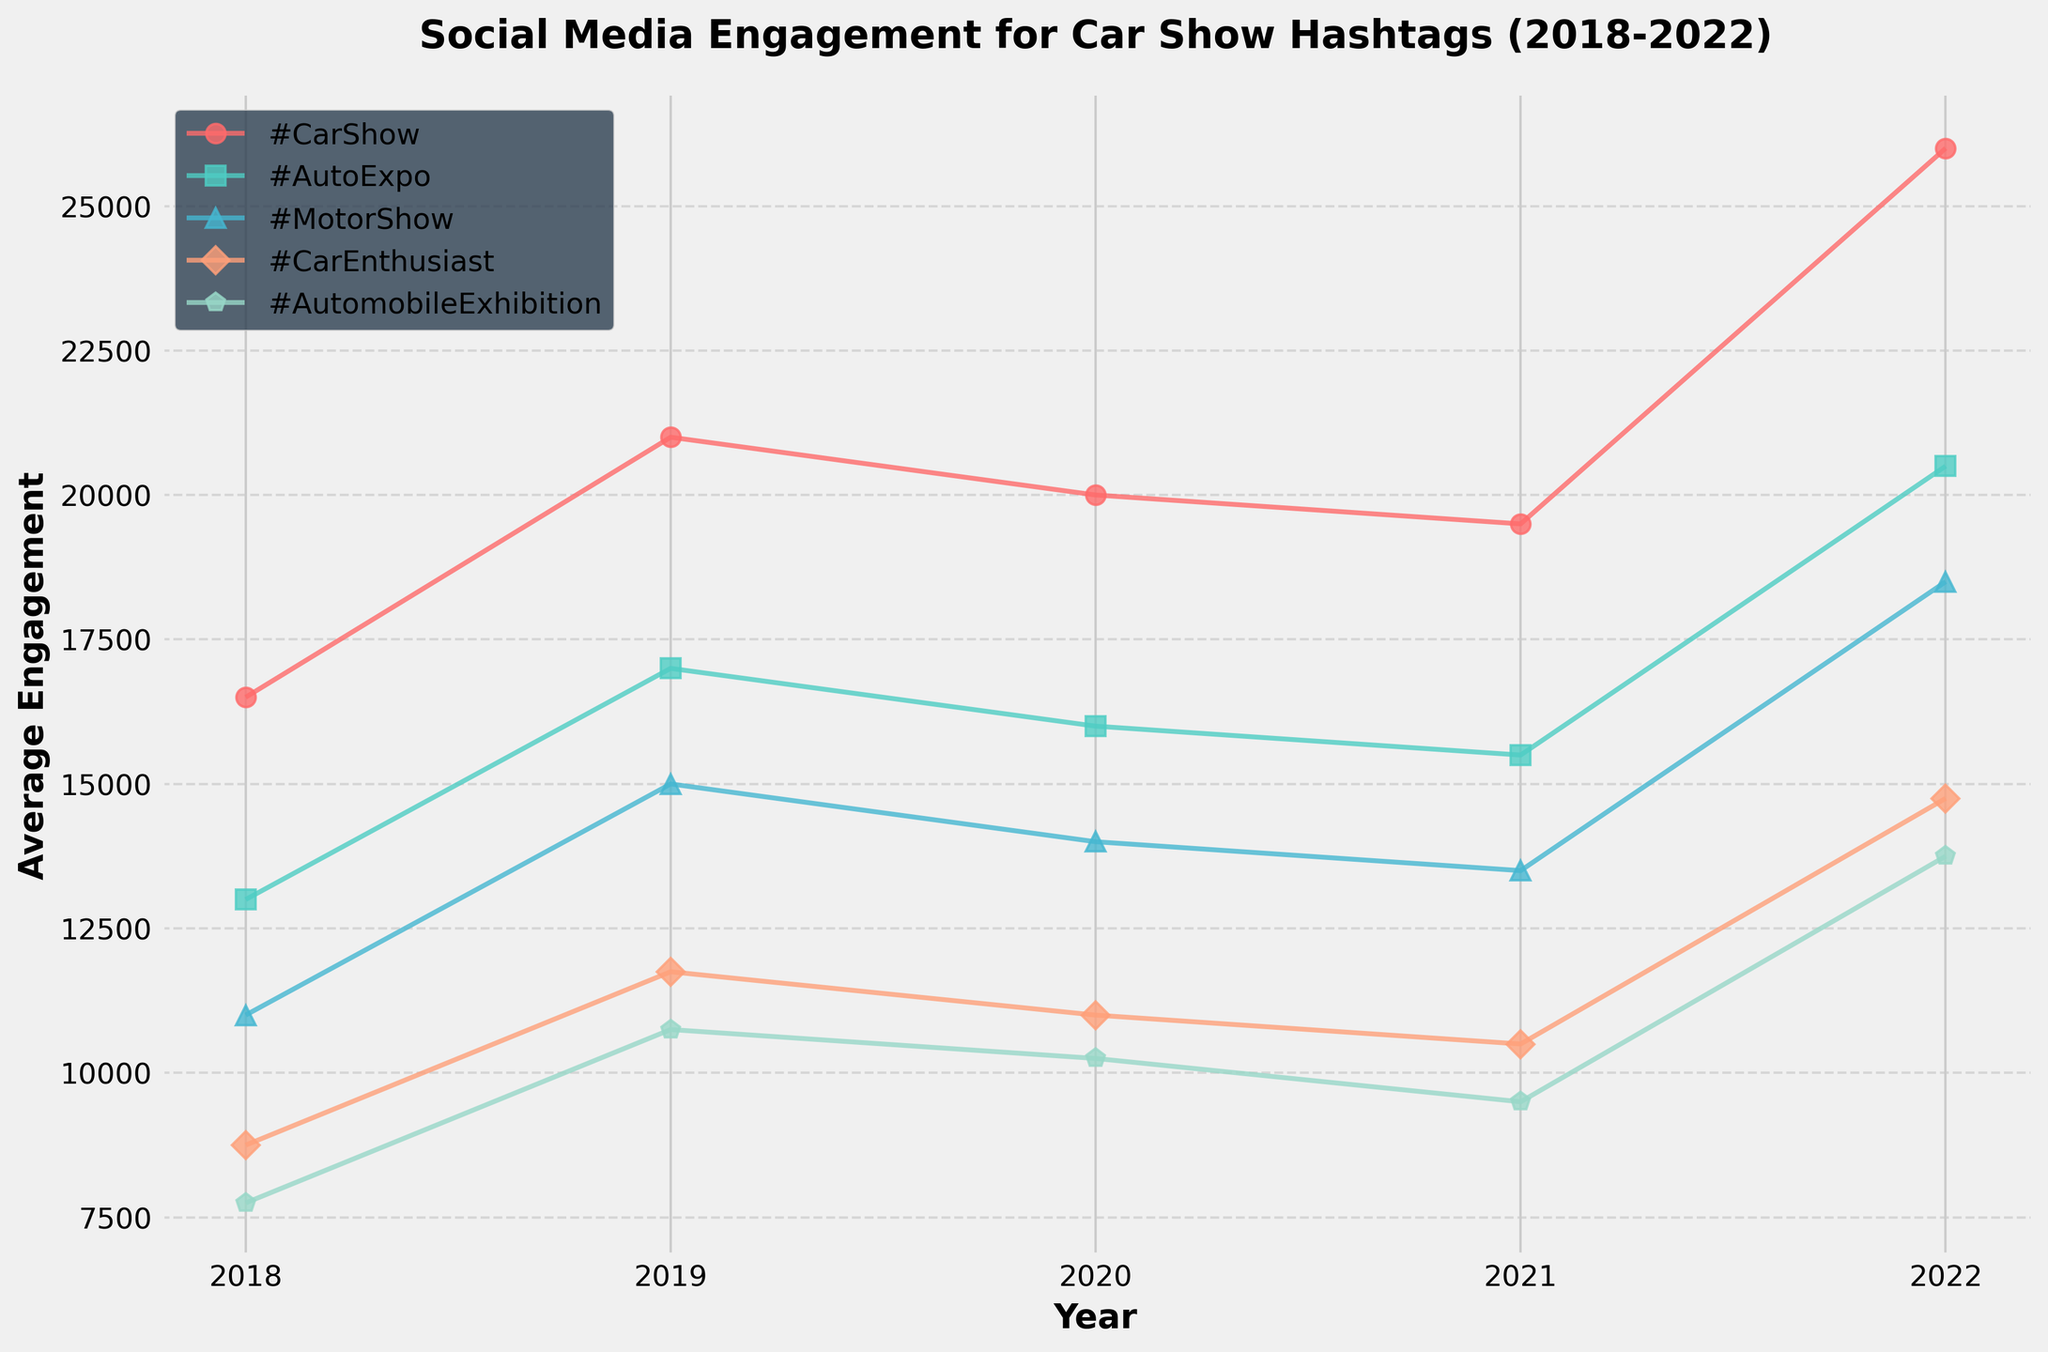What year had the highest average engagement across all hashtags? To find this, we need to visually assess the peak points for each hashtag line and note the year where the average engagement appears the highest. In 2022, most hashtags (#CarShow, #AutoExpo, etc.) show their highest values.
Answer: 2022 Which hashtag consistently increased in engagement from 2018 to 2022? Examine the engagement lines for each hashtag over the years, and look for a consistent upward trend. #CarShow is the hashtag with a consistent increase.
Answer: #CarShow How did the engagement for #MotorShow change from 2020 to 2021? Locate the points for #MotorShow in 2020 and 2021. In 2020, the engagement was significantly lower, and it increased in 2021.
Answer: Increased Which year experienced the drop in engagement for all hashtags? Look for the year where all lines dip compared to the previous year. In 2020, all hashtags dropped in engagement.
Answer: 2020 What is the color of the line representing #CarEnthusiast? Identify the color by observing the line and its associated legend entry. #CarEnthusiast is represented in orange.
Answer: Orange By how much did the average engagement for #AutoExpo increase from 2019 to 2022? Find the average engagement values for #AutoExpo in both 2019 and 2022. In 2019, the value is around 16,000, and in 2022, it's around 19,000. The increase is 19,000 - 16,000 = 3,000.
Answer: 3,000 Compare the average engagement of #CarShow and #AutomobileExhibition in 2019. Which had the higher value, and by how much? Locate the values for both hashtags in 2019. #CarShow is around 20,000, and #AutomobileExhibition is around 10,000. The difference is 20,000 - 10,000 = 10,000.
Answer: #CarShow, by 10,000 What was the trend for #CarEnthusiast from 2018 to 2021? Follow the line for #CarEnthusiast from 2018 to 2021. Initially, it increased from 2018 to 2019, then dropped in 2020, and increased again in 2021.
Answer: Increase, Decrease, Increase Which hashtag had the lowest average engagement in 2021? Check the positions of all lines in 2021, and identify the lowest one. #AutomobileExhibition had the lowest average engagement in 2021.
Answer: #AutomobileExhibition 